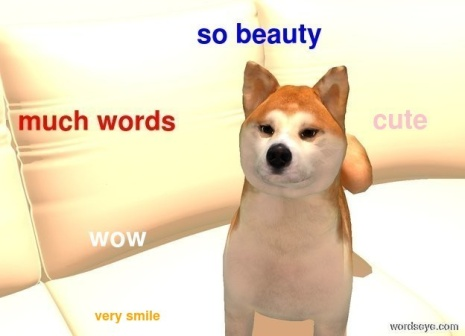If this Shiba Inu could talk, what do you think it would say? If this Shiba Inu could talk, it might say something like, "Hello, friend! Isn't today wonderful? I love sitting on this comfy couch and watching everything around me. Did you see that? Wow, so many interesting things! Let's play, and maybe later we can go for a walk. Much fun, very excitement, such good day!" Craft a whimsical poem about the Shiba Inu and its day. On a couch so bright, a Shiba rest,
With fur like cream, tan ears attest,
Eyes so round, filled with delight,
In a room bathed in golden light.

So beauty, it extends a glance,
Curious head tilt, an inquisitive stance,
Much words float in the air,
'Cute' and 'WOW' follow everywhere.

A walk in the sun, a chase in the yard,
Greeting new friends, tail wagging hard,
Such joy in the heart, as the day flies by,
Very smile, such happiness in its eye.

Evening falls, on the couch once more,
Dreaming of adventures, and fun galore,
With a heart so pure, a spirit so free,
Much love from this Shiba, eternally. Create a scenario where this image was part of an advertisement. Describe the advertisement and its tagline. Advertisement Description:
The scene opens with a close-up of the Shiba Inu on the white couch, its expressive eyes capturing the viewer's attention. The background is vivid, transitioning from warm orange to a soft yellow, evoking feelings of comfort and happiness. As the camera zooms out, the playful phrases like "so beauty", "much words", and "very smile" animate around the dog, emphasizing its charm and joy.

Tagline: "Comfort and Joy, Every Day – Find Your Happy Place with Our Cozy Home Furnishings."
The advertisement captures the essence of comfort and contentment, showcasing the Shiba Inu as the epitome of a happy home. The vibrant background and playful text overlay reinforce the message that our furnishings create a welcoming and cheerful atmosphere for both pets and humans. In a world where animals can communicate telepathically, what role would this Shiba Inu play in its community? In a world where animals can communicate telepathically, this Shiba Inu would play the role of a community ambassador. With its friendly and inquisitive nature, the Shiba Inu would bridge the gap between different species, fostering understanding and cooperation. It would be known for its wisdom and playful spirit, always ready to mediate disputes and share joyous moments. Its telepathic messages would be filled with positivity and encouragement, making it a beloved figure in the animal community. Whether organizing group activities or offering comforting words, this Shiba Inu's role is vital in maintaining harmony and happiness among its peers. 